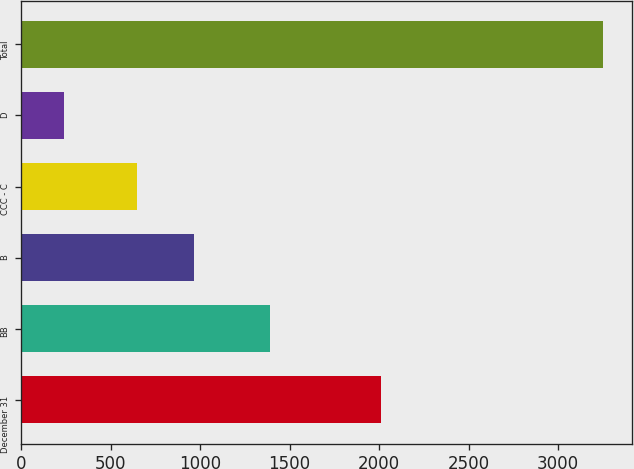<chart> <loc_0><loc_0><loc_500><loc_500><bar_chart><fcel>December 31<fcel>BB<fcel>B<fcel>CCC - C<fcel>D<fcel>Total<nl><fcel>2013<fcel>1393<fcel>967<fcel>649<fcel>241<fcel>3250<nl></chart> 